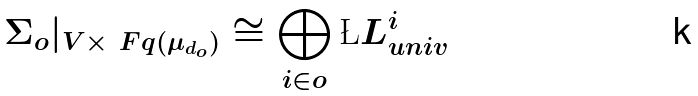Convert formula to latex. <formula><loc_0><loc_0><loc_500><loc_500>\Sigma _ { o } | _ { V \times \ F q ( \mu _ { d _ { o } } ) } \cong \bigoplus _ { i \in o } \L L _ { u n i v } ^ { i }</formula> 